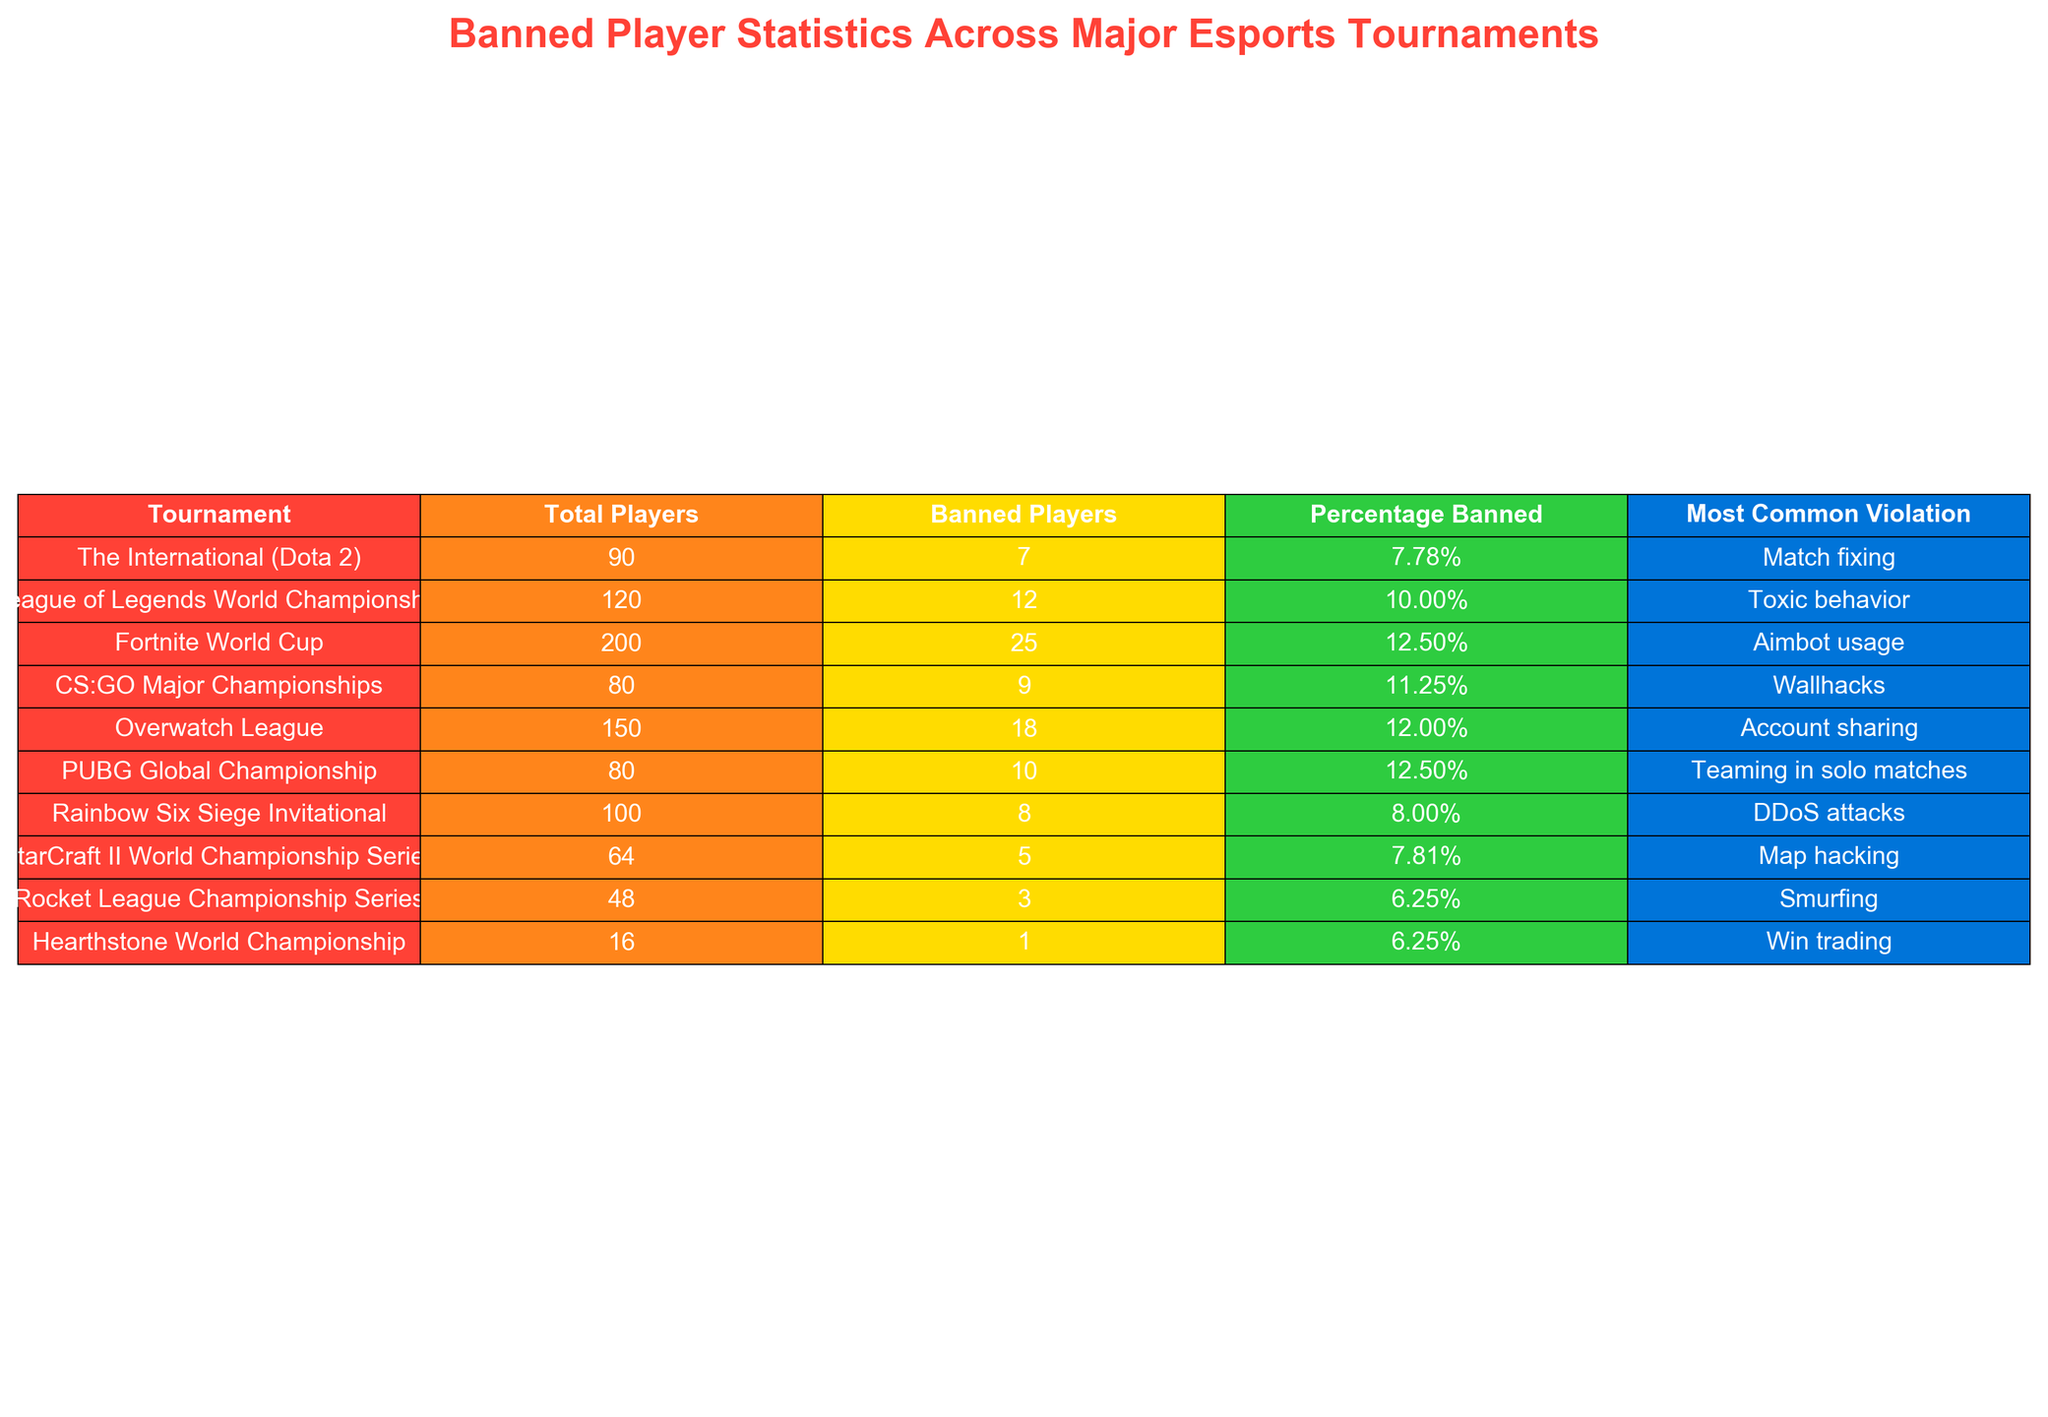What percentage of banned players is highest among the tournaments? The table shows the percentage of banned players across various tournaments. The maximum percentage appears to be 12.50%, which is listed under both the Fortnite World Cup and PUBG Global Championship.
Answer: 12.50% Which tournament had the most banned players? By observing the table, the tournament with the highest number of banned players is the Fortnite World Cup, with 25 banned players.
Answer: Fortnite World Cup What is the most common violation in CS:GO Major Championships? From the table, we can see that the most common violation listed for the CS:GO Major Championships is wallhacks.
Answer: Wallhacks How many total players were there across all tournaments? We will sum the total players from each tournament: 90 + 120 + 200 + 80 + 150 + 80 + 100 + 64 + 48 + 16 = 1050.
Answer: 1050 Is the percentage of banned players in Overwatch League greater than in Rainbow Six Siege Invitational? The table shows that Overwatch League has 12.00% of banned players while Rainbow Six Siege Invitational has 8.00%. Since 12.00% is greater than 8.00%, the statement is true.
Answer: Yes What is the average percentage of banned players across all tournaments? To find the average percentage, we sum all the percentages: 7.78 + 10.00 + 12.50 + 11.25 + 12.00 + 12.50 + 8.00 + 7.81 + 6.25 + 6.25 =  88.09. Then divide by the number of tournaments (10) to get the average: 88.09/10 = 8.809%.
Answer: 8.81% Which tournament has a violation of "Match fixing"? The table shows that the violation "Match fixing" is associated with The International Dota 2 tournament.
Answer: The International Dota 2 If we compare the number of banned players to total players, what is the difference for League of Legends World Championship? The number of banned players in League of Legends World Championship is 12 and total players are 120. The difference is 120 - 12 = 108.
Answer: 108 